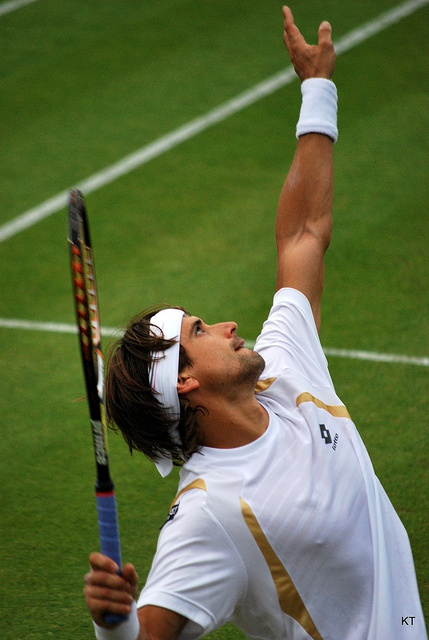Describe the objects in this image and their specific colors. I can see people in darkgreen, lavender, black, and darkgray tones and tennis racket in darkgreen, black, navy, and gray tones in this image. 